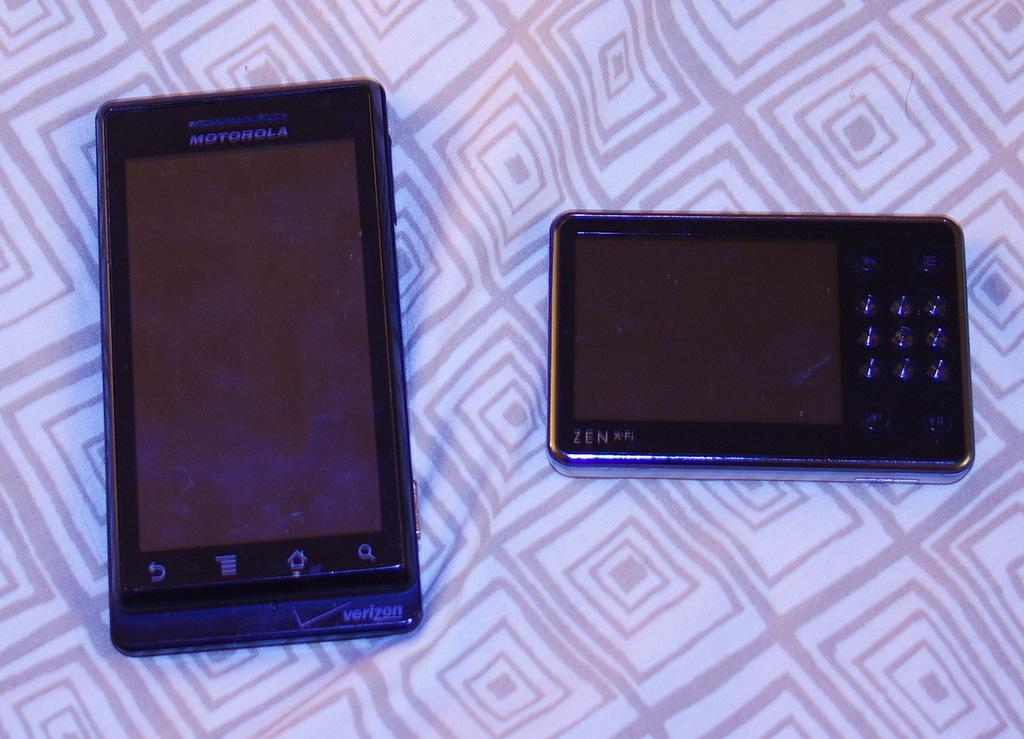<image>
Provide a brief description of the given image. A black Motorola cell phone and a black ZEN X-Fi device laying on top of some type of material. 